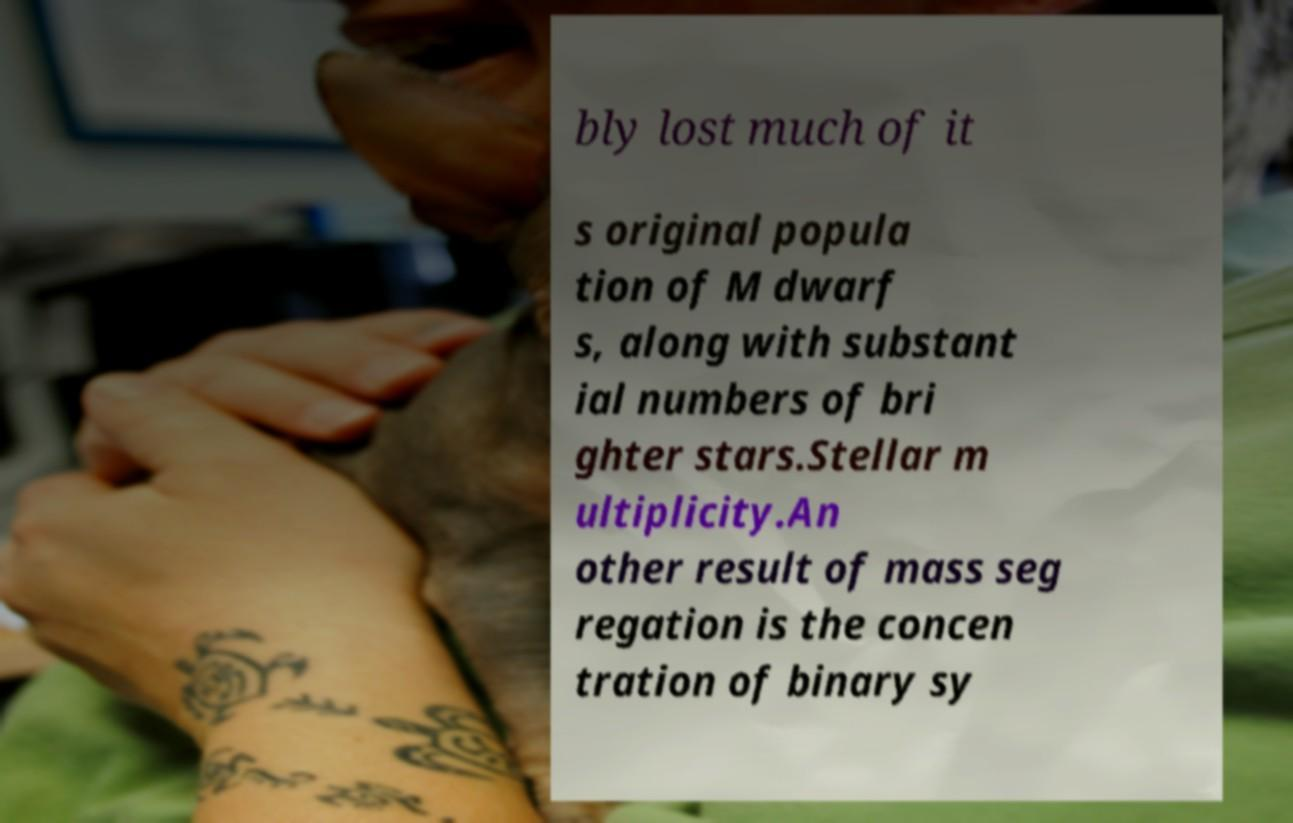I need the written content from this picture converted into text. Can you do that? bly lost much of it s original popula tion of M dwarf s, along with substant ial numbers of bri ghter stars.Stellar m ultiplicity.An other result of mass seg regation is the concen tration of binary sy 